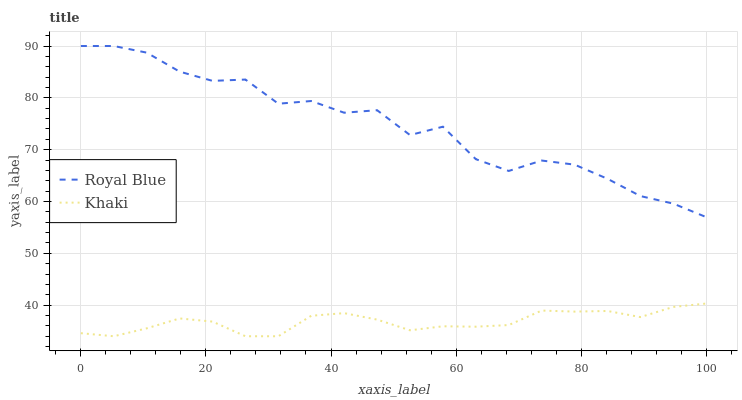Does Khaki have the minimum area under the curve?
Answer yes or no. Yes. Does Royal Blue have the maximum area under the curve?
Answer yes or no. Yes. Does Khaki have the maximum area under the curve?
Answer yes or no. No. Is Khaki the smoothest?
Answer yes or no. Yes. Is Royal Blue the roughest?
Answer yes or no. Yes. Is Khaki the roughest?
Answer yes or no. No. Does Khaki have the lowest value?
Answer yes or no. Yes. Does Royal Blue have the highest value?
Answer yes or no. Yes. Does Khaki have the highest value?
Answer yes or no. No. Is Khaki less than Royal Blue?
Answer yes or no. Yes. Is Royal Blue greater than Khaki?
Answer yes or no. Yes. Does Khaki intersect Royal Blue?
Answer yes or no. No. 